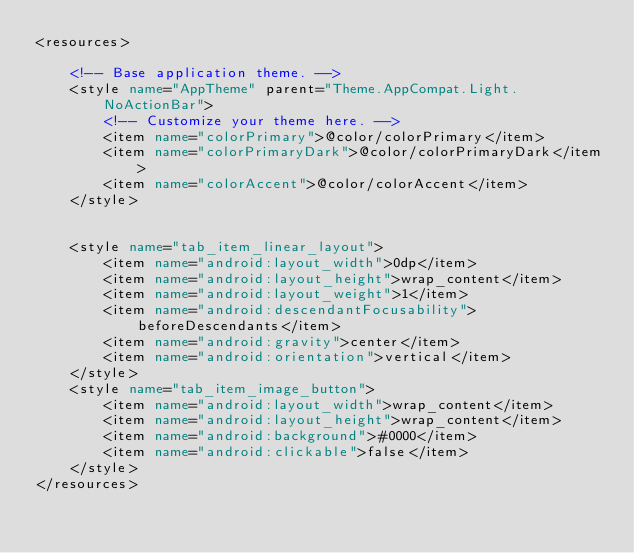Convert code to text. <code><loc_0><loc_0><loc_500><loc_500><_XML_><resources>

    <!-- Base application theme. -->
    <style name="AppTheme" parent="Theme.AppCompat.Light.NoActionBar">
        <!-- Customize your theme here. -->
        <item name="colorPrimary">@color/colorPrimary</item>
        <item name="colorPrimaryDark">@color/colorPrimaryDark</item>
        <item name="colorAccent">@color/colorAccent</item>
    </style>


    <style name="tab_item_linear_layout">
        <item name="android:layout_width">0dp</item>
        <item name="android:layout_height">wrap_content</item>
        <item name="android:layout_weight">1</item>
        <item name="android:descendantFocusability">beforeDescendants</item>
        <item name="android:gravity">center</item>
        <item name="android:orientation">vertical</item>
    </style>
    <style name="tab_item_image_button">
        <item name="android:layout_width">wrap_content</item>
        <item name="android:layout_height">wrap_content</item>
        <item name="android:background">#0000</item>
        <item name="android:clickable">false</item>
    </style>
</resources>
</code> 